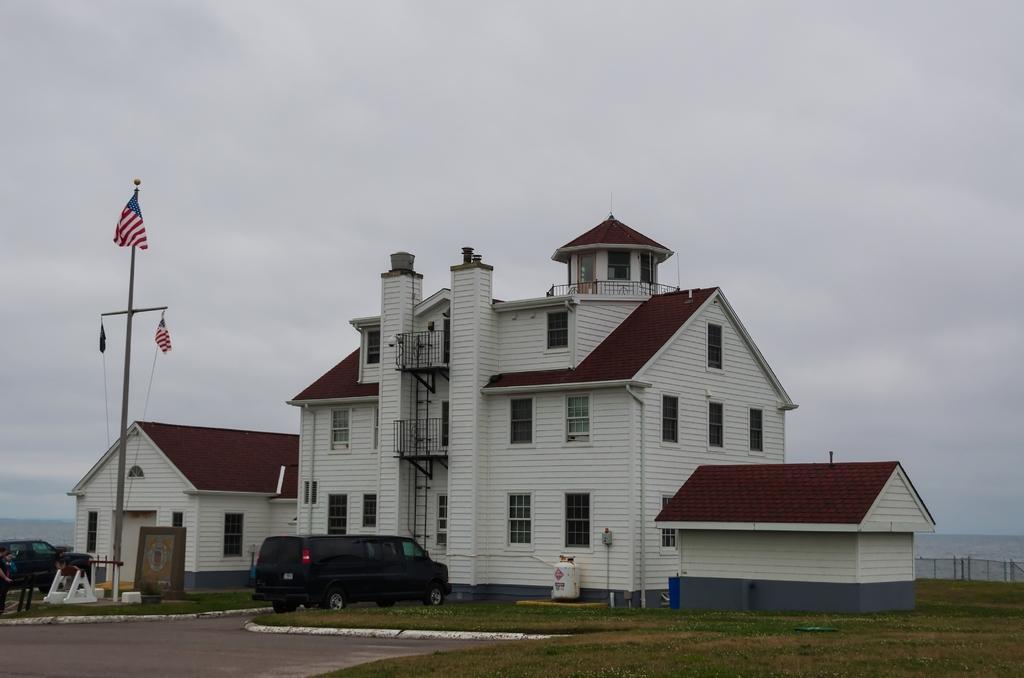Could you give a brief overview of what you see in this image? In this image I can see a building which is white and brown in color and a vehicle which is black in color in front of the building on the road. I can see a person standing, other car which is black in color and a flag. In the background I can see the sky. 